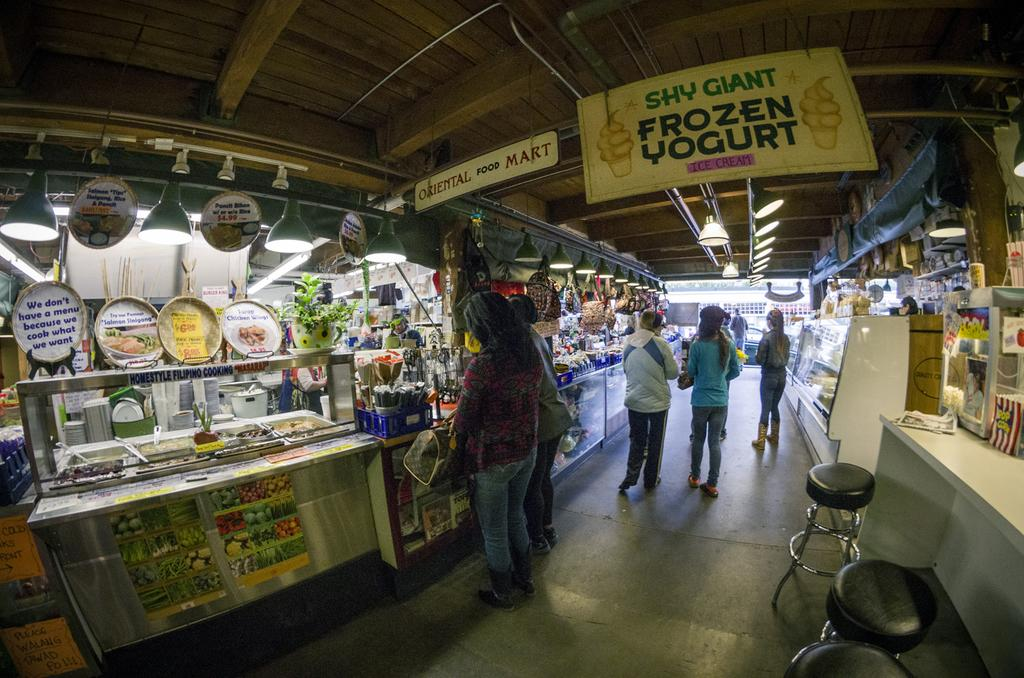<image>
Offer a succinct explanation of the picture presented. A hanging sign in an alley store that says Frozen Yogurt 